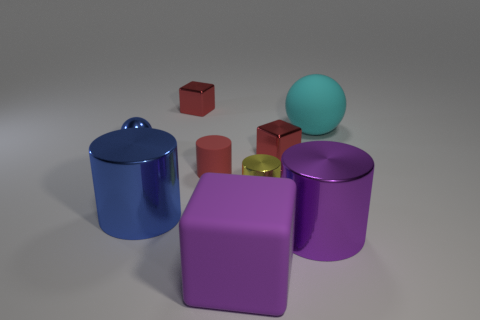The metal thing that is the same color as the rubber block is what shape?
Make the answer very short. Cylinder. There is another rubber object that is the same size as the cyan rubber thing; what is its color?
Offer a terse response. Purple. There is a small rubber cylinder; does it have the same color as the tiny metallic cube that is in front of the large cyan ball?
Ensure brevity in your answer.  Yes. How many other things are there of the same size as the blue cylinder?
Give a very brief answer. 3. There is another small object that is the same shape as the small yellow metal object; what is its color?
Your answer should be compact. Red. There is a yellow thing that is the same shape as the big blue shiny object; what size is it?
Give a very brief answer. Small. Is the size of the red matte thing the same as the shiny sphere?
Offer a very short reply. Yes. Is the number of tiny red metallic things that are in front of the tiny blue metal object the same as the number of small metallic objects?
Make the answer very short. No. Is there a red matte cylinder right of the metallic cylinder that is to the right of the red cube to the right of the small metal cylinder?
Make the answer very short. No. What color is the sphere that is made of the same material as the large blue object?
Ensure brevity in your answer.  Blue. 